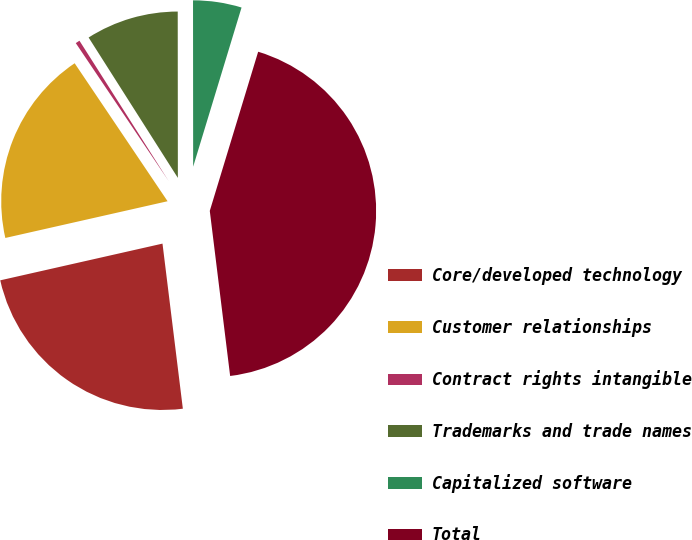Convert chart. <chart><loc_0><loc_0><loc_500><loc_500><pie_chart><fcel>Core/developed technology<fcel>Customer relationships<fcel>Contract rights intangible<fcel>Trademarks and trade names<fcel>Capitalized software<fcel>Total<nl><fcel>23.41%<fcel>19.11%<fcel>0.42%<fcel>9.0%<fcel>4.71%<fcel>43.35%<nl></chart> 